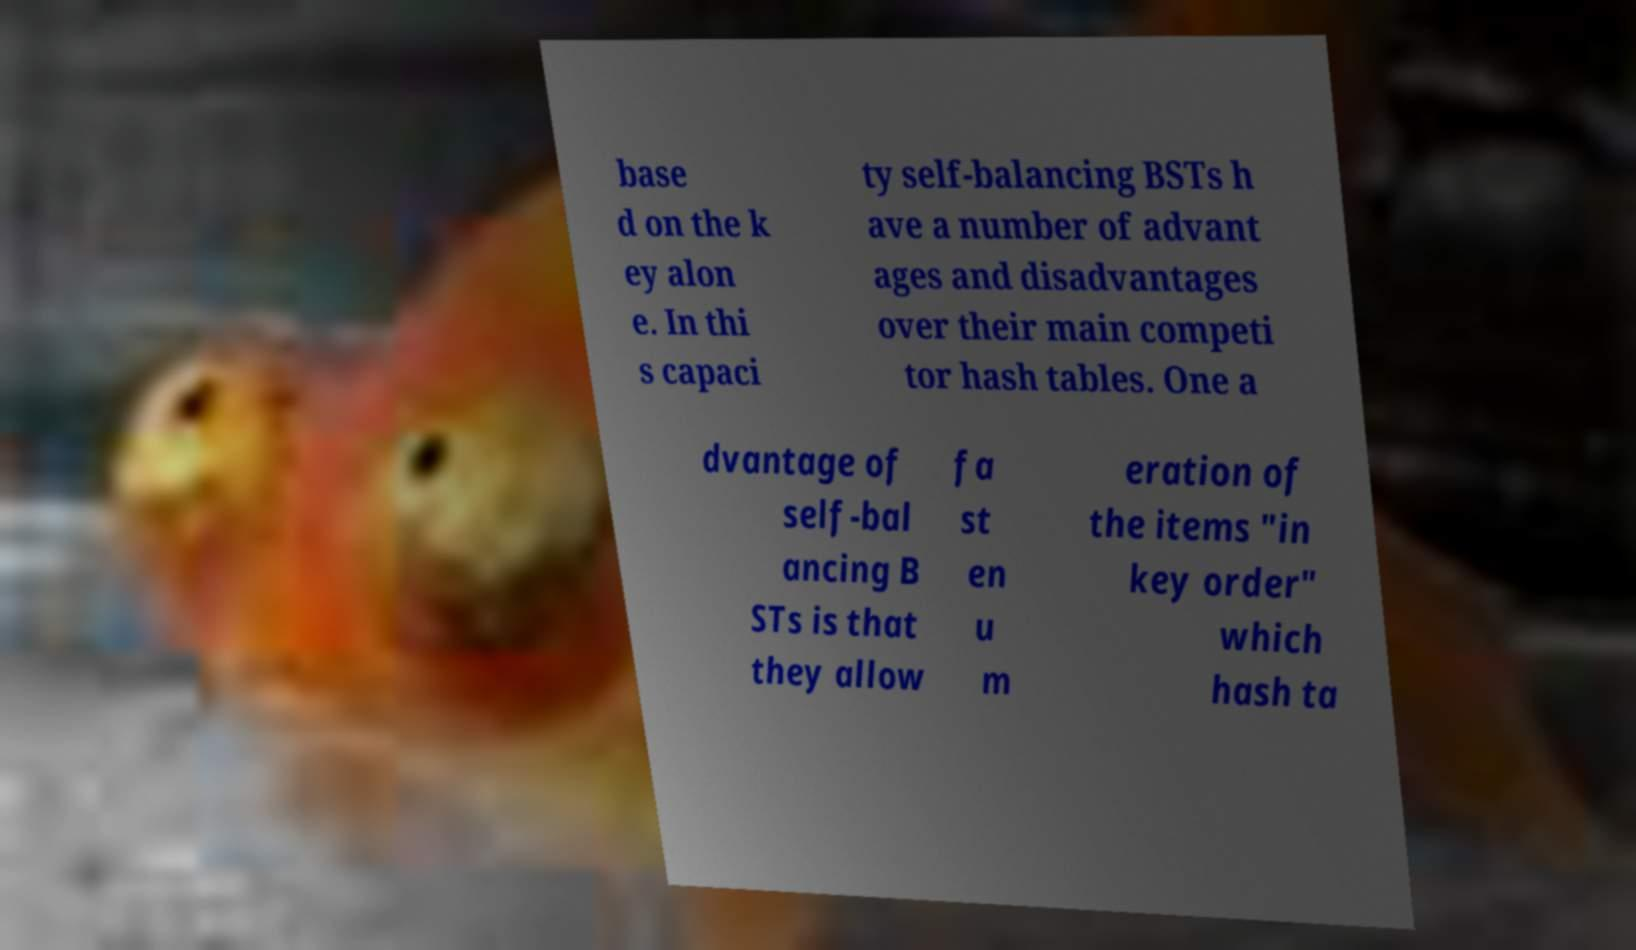Please identify and transcribe the text found in this image. base d on the k ey alon e. In thi s capaci ty self-balancing BSTs h ave a number of advant ages and disadvantages over their main competi tor hash tables. One a dvantage of self-bal ancing B STs is that they allow fa st en u m eration of the items "in key order" which hash ta 